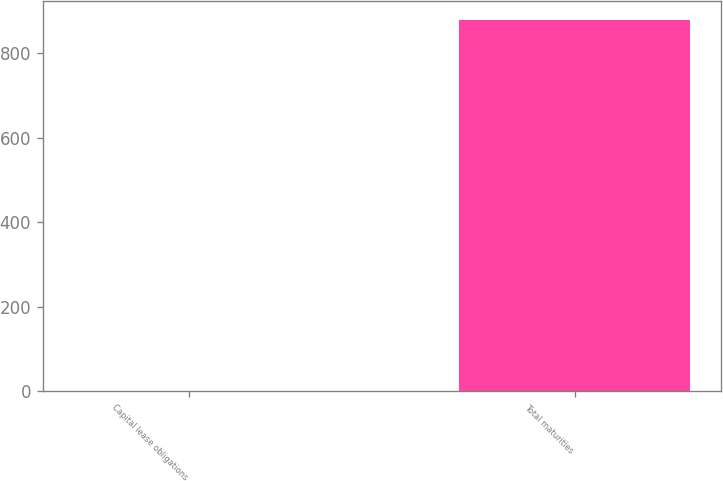Convert chart. <chart><loc_0><loc_0><loc_500><loc_500><bar_chart><fcel>Capital lease obligations<fcel>Total maturities<nl><fcel>0.5<fcel>879.4<nl></chart> 